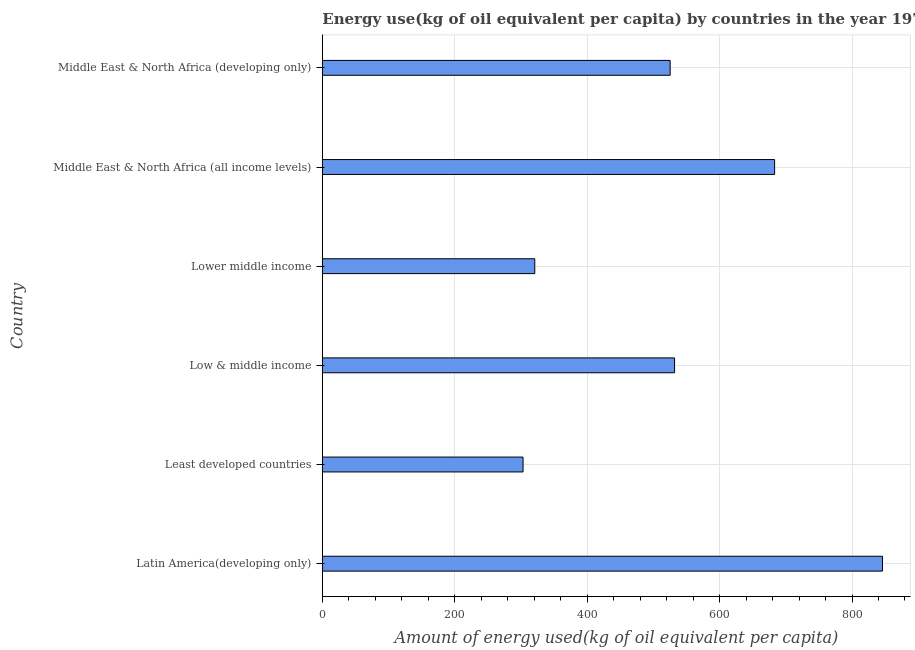Does the graph contain any zero values?
Provide a short and direct response. No. What is the title of the graph?
Give a very brief answer. Energy use(kg of oil equivalent per capita) by countries in the year 1977. What is the label or title of the X-axis?
Your answer should be very brief. Amount of energy used(kg of oil equivalent per capita). What is the label or title of the Y-axis?
Keep it short and to the point. Country. What is the amount of energy used in Least developed countries?
Your answer should be compact. 303.17. Across all countries, what is the maximum amount of energy used?
Your response must be concise. 846.04. Across all countries, what is the minimum amount of energy used?
Your answer should be compact. 303.17. In which country was the amount of energy used maximum?
Offer a terse response. Latin America(developing only). In which country was the amount of energy used minimum?
Make the answer very short. Least developed countries. What is the sum of the amount of energy used?
Give a very brief answer. 3210.52. What is the difference between the amount of energy used in Least developed countries and Low & middle income?
Your answer should be very brief. -228.84. What is the average amount of energy used per country?
Ensure brevity in your answer.  535.09. What is the median amount of energy used?
Your answer should be very brief. 528.67. What is the ratio of the amount of energy used in Latin America(developing only) to that in Low & middle income?
Provide a succinct answer. 1.59. Is the difference between the amount of energy used in Lower middle income and Middle East & North Africa (all income levels) greater than the difference between any two countries?
Give a very brief answer. No. What is the difference between the highest and the second highest amount of energy used?
Make the answer very short. 162.93. Is the sum of the amount of energy used in Latin America(developing only) and Middle East & North Africa (developing only) greater than the maximum amount of energy used across all countries?
Give a very brief answer. Yes. What is the difference between the highest and the lowest amount of energy used?
Ensure brevity in your answer.  542.87. What is the difference between two consecutive major ticks on the X-axis?
Give a very brief answer. 200. Are the values on the major ticks of X-axis written in scientific E-notation?
Ensure brevity in your answer.  No. What is the Amount of energy used(kg of oil equivalent per capita) of Latin America(developing only)?
Your answer should be very brief. 846.04. What is the Amount of energy used(kg of oil equivalent per capita) in Least developed countries?
Provide a succinct answer. 303.17. What is the Amount of energy used(kg of oil equivalent per capita) in Low & middle income?
Your answer should be compact. 532. What is the Amount of energy used(kg of oil equivalent per capita) of Lower middle income?
Keep it short and to the point. 320.85. What is the Amount of energy used(kg of oil equivalent per capita) in Middle East & North Africa (all income levels)?
Give a very brief answer. 683.11. What is the Amount of energy used(kg of oil equivalent per capita) in Middle East & North Africa (developing only)?
Give a very brief answer. 525.34. What is the difference between the Amount of energy used(kg of oil equivalent per capita) in Latin America(developing only) and Least developed countries?
Ensure brevity in your answer.  542.87. What is the difference between the Amount of energy used(kg of oil equivalent per capita) in Latin America(developing only) and Low & middle income?
Give a very brief answer. 314.04. What is the difference between the Amount of energy used(kg of oil equivalent per capita) in Latin America(developing only) and Lower middle income?
Provide a short and direct response. 525.19. What is the difference between the Amount of energy used(kg of oil equivalent per capita) in Latin America(developing only) and Middle East & North Africa (all income levels)?
Keep it short and to the point. 162.93. What is the difference between the Amount of energy used(kg of oil equivalent per capita) in Latin America(developing only) and Middle East & North Africa (developing only)?
Give a very brief answer. 320.7. What is the difference between the Amount of energy used(kg of oil equivalent per capita) in Least developed countries and Low & middle income?
Give a very brief answer. -228.83. What is the difference between the Amount of energy used(kg of oil equivalent per capita) in Least developed countries and Lower middle income?
Provide a succinct answer. -17.68. What is the difference between the Amount of energy used(kg of oil equivalent per capita) in Least developed countries and Middle East & North Africa (all income levels)?
Your answer should be very brief. -379.94. What is the difference between the Amount of energy used(kg of oil equivalent per capita) in Least developed countries and Middle East & North Africa (developing only)?
Your answer should be compact. -222.17. What is the difference between the Amount of energy used(kg of oil equivalent per capita) in Low & middle income and Lower middle income?
Ensure brevity in your answer.  211.16. What is the difference between the Amount of energy used(kg of oil equivalent per capita) in Low & middle income and Middle East & North Africa (all income levels)?
Provide a succinct answer. -151.11. What is the difference between the Amount of energy used(kg of oil equivalent per capita) in Low & middle income and Middle East & North Africa (developing only)?
Offer a terse response. 6.66. What is the difference between the Amount of energy used(kg of oil equivalent per capita) in Lower middle income and Middle East & North Africa (all income levels)?
Offer a very short reply. -362.26. What is the difference between the Amount of energy used(kg of oil equivalent per capita) in Lower middle income and Middle East & North Africa (developing only)?
Keep it short and to the point. -204.49. What is the difference between the Amount of energy used(kg of oil equivalent per capita) in Middle East & North Africa (all income levels) and Middle East & North Africa (developing only)?
Provide a short and direct response. 157.77. What is the ratio of the Amount of energy used(kg of oil equivalent per capita) in Latin America(developing only) to that in Least developed countries?
Ensure brevity in your answer.  2.79. What is the ratio of the Amount of energy used(kg of oil equivalent per capita) in Latin America(developing only) to that in Low & middle income?
Your answer should be compact. 1.59. What is the ratio of the Amount of energy used(kg of oil equivalent per capita) in Latin America(developing only) to that in Lower middle income?
Keep it short and to the point. 2.64. What is the ratio of the Amount of energy used(kg of oil equivalent per capita) in Latin America(developing only) to that in Middle East & North Africa (all income levels)?
Your answer should be very brief. 1.24. What is the ratio of the Amount of energy used(kg of oil equivalent per capita) in Latin America(developing only) to that in Middle East & North Africa (developing only)?
Your answer should be compact. 1.61. What is the ratio of the Amount of energy used(kg of oil equivalent per capita) in Least developed countries to that in Low & middle income?
Provide a succinct answer. 0.57. What is the ratio of the Amount of energy used(kg of oil equivalent per capita) in Least developed countries to that in Lower middle income?
Provide a succinct answer. 0.94. What is the ratio of the Amount of energy used(kg of oil equivalent per capita) in Least developed countries to that in Middle East & North Africa (all income levels)?
Your answer should be very brief. 0.44. What is the ratio of the Amount of energy used(kg of oil equivalent per capita) in Least developed countries to that in Middle East & North Africa (developing only)?
Your answer should be very brief. 0.58. What is the ratio of the Amount of energy used(kg of oil equivalent per capita) in Low & middle income to that in Lower middle income?
Make the answer very short. 1.66. What is the ratio of the Amount of energy used(kg of oil equivalent per capita) in Low & middle income to that in Middle East & North Africa (all income levels)?
Ensure brevity in your answer.  0.78. What is the ratio of the Amount of energy used(kg of oil equivalent per capita) in Lower middle income to that in Middle East & North Africa (all income levels)?
Keep it short and to the point. 0.47. What is the ratio of the Amount of energy used(kg of oil equivalent per capita) in Lower middle income to that in Middle East & North Africa (developing only)?
Provide a succinct answer. 0.61. What is the ratio of the Amount of energy used(kg of oil equivalent per capita) in Middle East & North Africa (all income levels) to that in Middle East & North Africa (developing only)?
Keep it short and to the point. 1.3. 